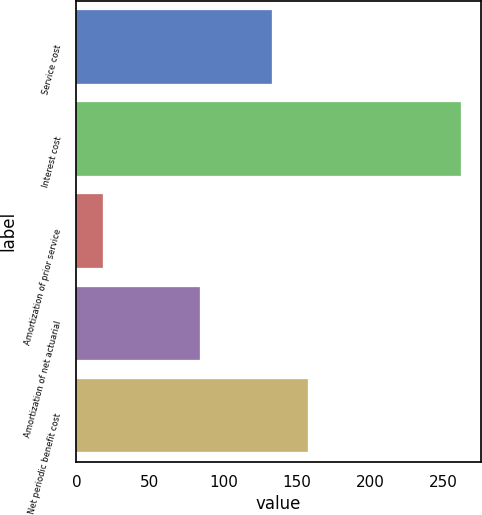<chart> <loc_0><loc_0><loc_500><loc_500><bar_chart><fcel>Service cost<fcel>Interest cost<fcel>Amortization of prior service<fcel>Amortization of net actuarial<fcel>Net periodic benefit cost<nl><fcel>133<fcel>262<fcel>18<fcel>84<fcel>157.4<nl></chart> 